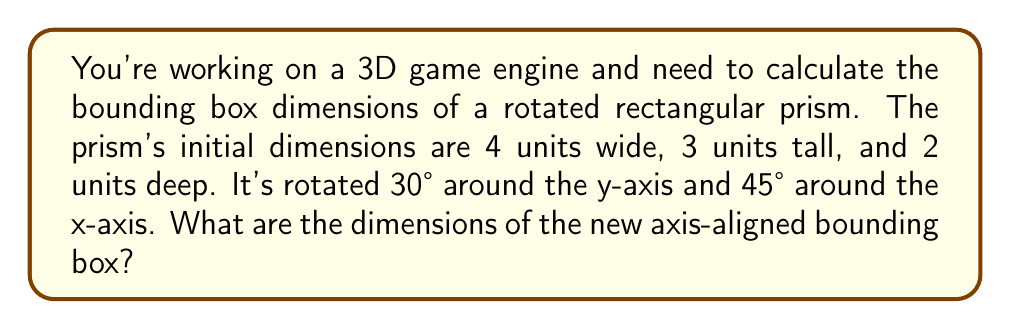Give your solution to this math problem. To solve this problem, we'll follow these steps:

1) First, we need to understand that rotating an object doesn't change its size, but it does change how much space it occupies along each axis.

2) We can use the rotation matrix to find the new coordinates of each vertex of the prism after rotation. However, a simpler method exists for rectangular prisms.

3) For a rectangular prism, the dimensions of the bounding box after rotation can be calculated using the following formula:

   $$d' = |R_x| \cdot d$$

   Where $d'$ is the new dimension vector, $R_x$ is the rotation matrix, and $d$ is the original dimension vector.

4) The rotation matrix for a rotation around the y-axis by $\theta$ and around the x-axis by $\phi$ is:

   $$R = \begin{bmatrix}
   \cos\theta & 0 & \sin\theta \\
   \sin\phi\sin\theta & \cos\phi & -\sin\phi\cos\theta \\
   -\cos\phi\sin\theta & \sin\phi & \cos\phi\cos\theta
   \end{bmatrix}$$

5) Plugging in our values ($\theta = 30°$, $\phi = 45°$):

   $$R = \begin{bmatrix}
   \frac{\sqrt{3}}{2} & 0 & \frac{1}{2} \\
   \frac{1}{2\sqrt{2}} & \frac{\sqrt{2}}{2} & -\frac{\sqrt{3}}{2\sqrt{2}} \\
   -\frac{\sqrt{3}}{2\sqrt{2}} & \frac{\sqrt{2}}{2} & \frac{1}{2\sqrt{2}}
   \end{bmatrix}$$

6) Now, we take the absolute value of each element in this matrix and multiply it by our original dimensions [4, 3, 2]:

   $$d' = \begin{bmatrix}
   \frac{\sqrt{3}}{2} & 0 & \frac{1}{2} \\
   \frac{1}{2\sqrt{2}} & \frac{\sqrt{2}}{2} & \frac{\sqrt{3}}{2\sqrt{2}} \\
   \frac{\sqrt{3}}{2\sqrt{2}} & \frac{\sqrt{2}}{2} & \frac{1}{2\sqrt{2}}
   \end{bmatrix} \cdot \begin{bmatrix} 4 \\ 3 \\ 2 \end{bmatrix}$$

7) Calculating this:

   $$d' = \begin{bmatrix}
   4 \cdot \frac{\sqrt{3}}{2} + 2 \cdot \frac{1}{2} \\
   4 \cdot \frac{1}{2\sqrt{2}} + 3 \cdot \frac{\sqrt{2}}{2} + 2 \cdot \frac{\sqrt{3}}{2\sqrt{2}} \\
   4 \cdot \frac{\sqrt{3}}{2\sqrt{2}} + 3 \cdot \frac{\sqrt{2}}{2} + 2 \cdot \frac{1}{2\sqrt{2}}
   \end{bmatrix} \approx \begin{bmatrix}
   4.46 \\
   3.83 \\
   3.83
   \end{bmatrix}$$

These are the dimensions of the new axis-aligned bounding box.
Answer: 4.46 x 3.83 x 3.83 units 